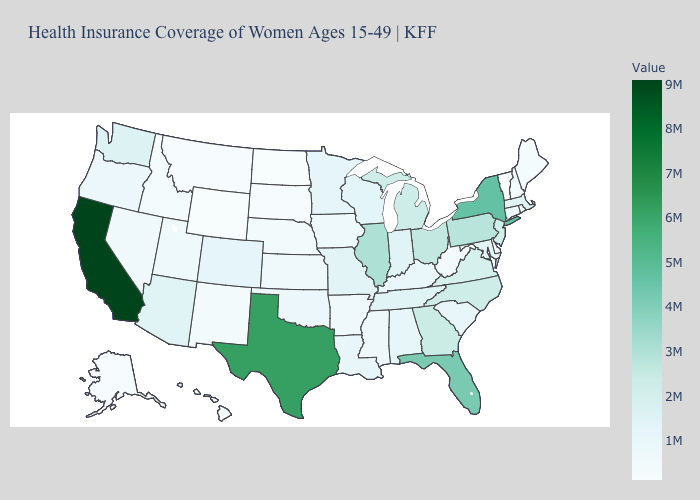Does the map have missing data?
Write a very short answer. No. Among the states that border Vermont , does New York have the lowest value?
Short answer required. No. Among the states that border Louisiana , does Arkansas have the lowest value?
Concise answer only. Yes. Which states have the lowest value in the USA?
Give a very brief answer. Wyoming. Which states have the lowest value in the Northeast?
Short answer required. Vermont. Which states have the highest value in the USA?
Answer briefly. California. Among the states that border Vermont , which have the highest value?
Answer briefly. New York. Does Alabama have the highest value in the USA?
Give a very brief answer. No. 